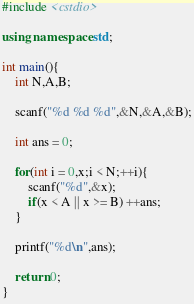<code> <loc_0><loc_0><loc_500><loc_500><_C++_>#include <cstdio>

using namespace std;

int main(){
    int N,A,B;

    scanf("%d %d %d",&N,&A,&B);

    int ans = 0;

    for(int i = 0,x;i < N;++i){
        scanf("%d",&x);
        if(x < A || x >= B) ++ans;
    }

    printf("%d\n",ans);

    return 0;
}
</code> 